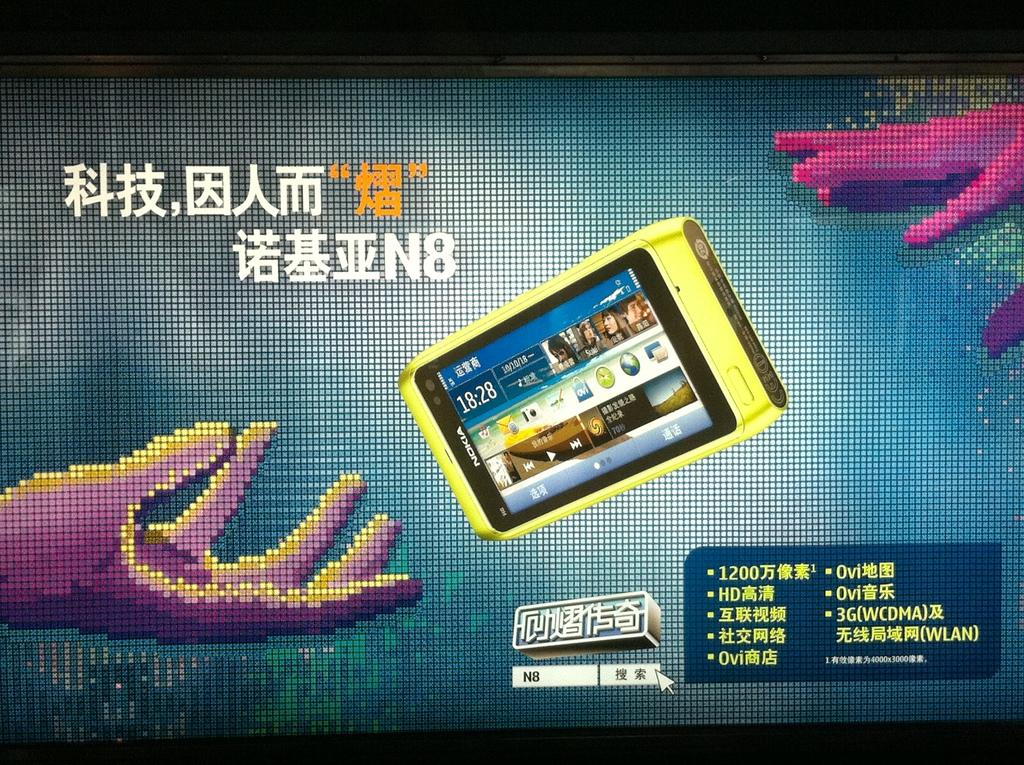Provide a one-sentence caption for the provided image. A large screen with Chinese writing and two hands reaching for a cell phone that reads, 18:28. 